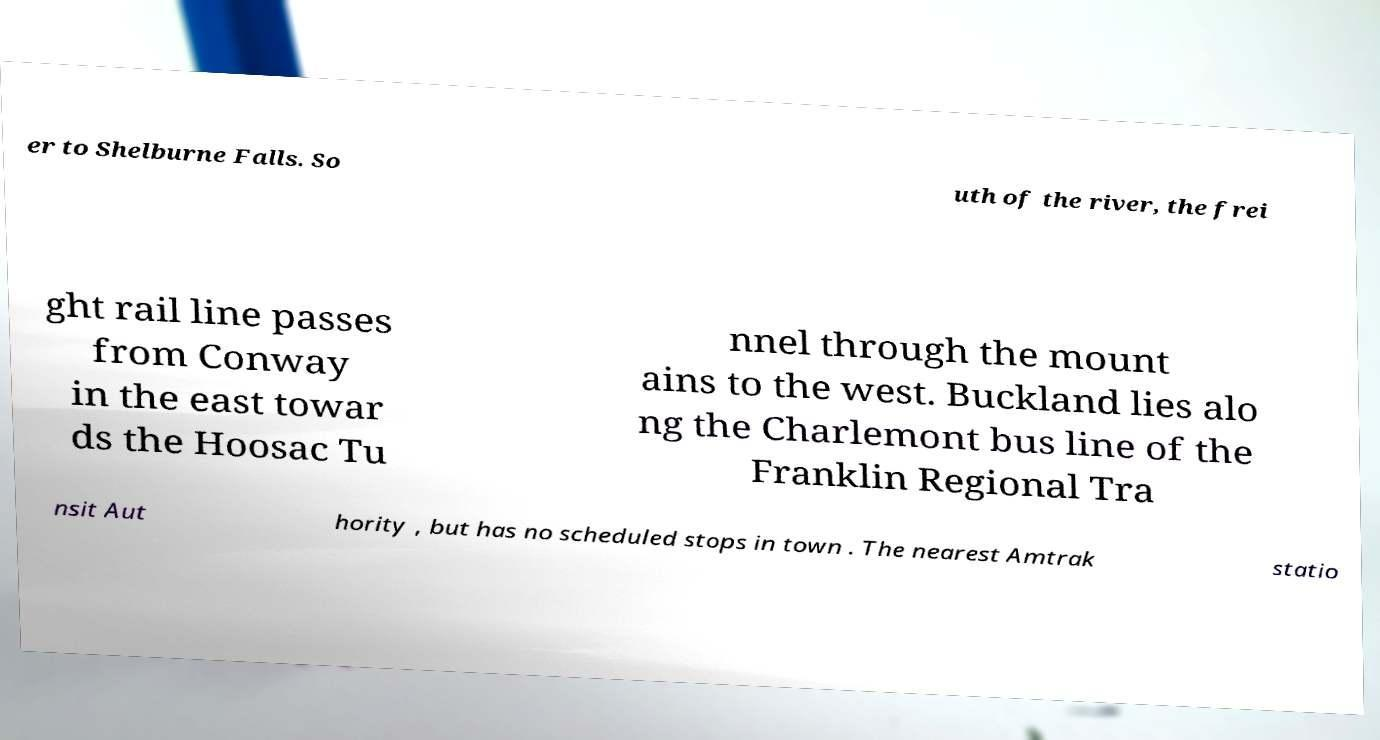Could you assist in decoding the text presented in this image and type it out clearly? er to Shelburne Falls. So uth of the river, the frei ght rail line passes from Conway in the east towar ds the Hoosac Tu nnel through the mount ains to the west. Buckland lies alo ng the Charlemont bus line of the Franklin Regional Tra nsit Aut hority , but has no scheduled stops in town . The nearest Amtrak statio 